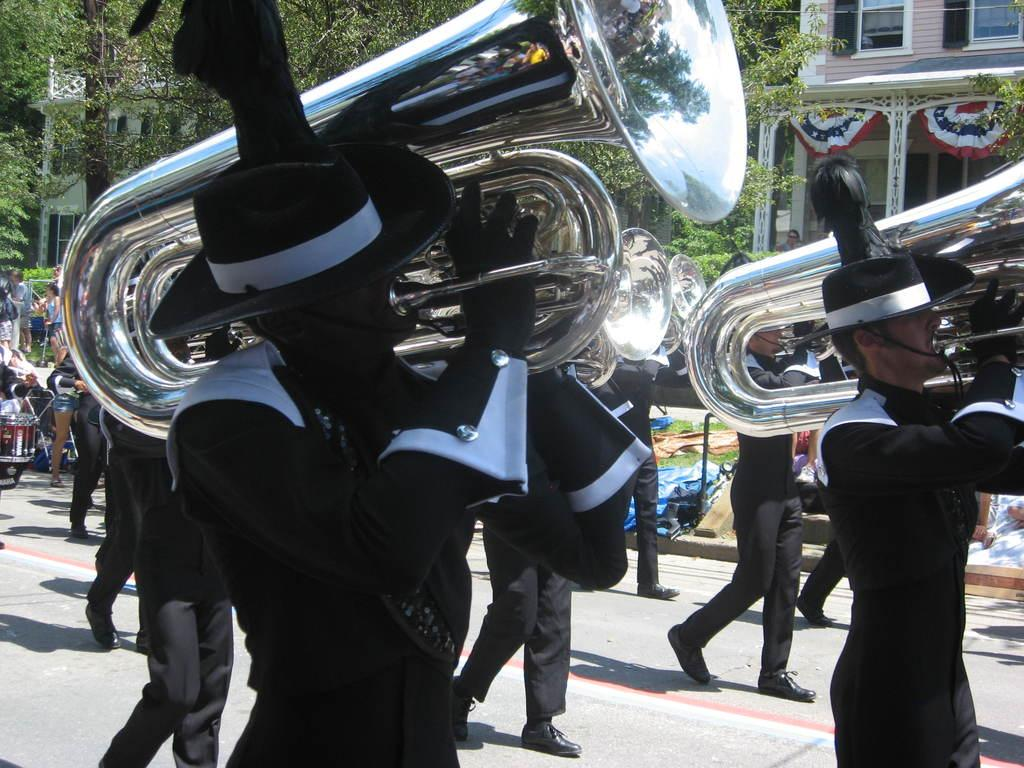How many people are in the image? There is a group of people in the image, but the exact number is not specified. What are some of the people doing in the image? Some of the people are walking, and some are playing musical instruments. What can be seen in the background of the image? There are buildings and trees in the background of the image. What is at the bottom of the image? There is a road at the bottom of the image. What type of vegetation is present in the image? There is grass in the image. Where is the mark on the fish in the image? There is no fish or mark present in the image. What type of basket is being used by the people in the image? There is no basket visible in the image. 